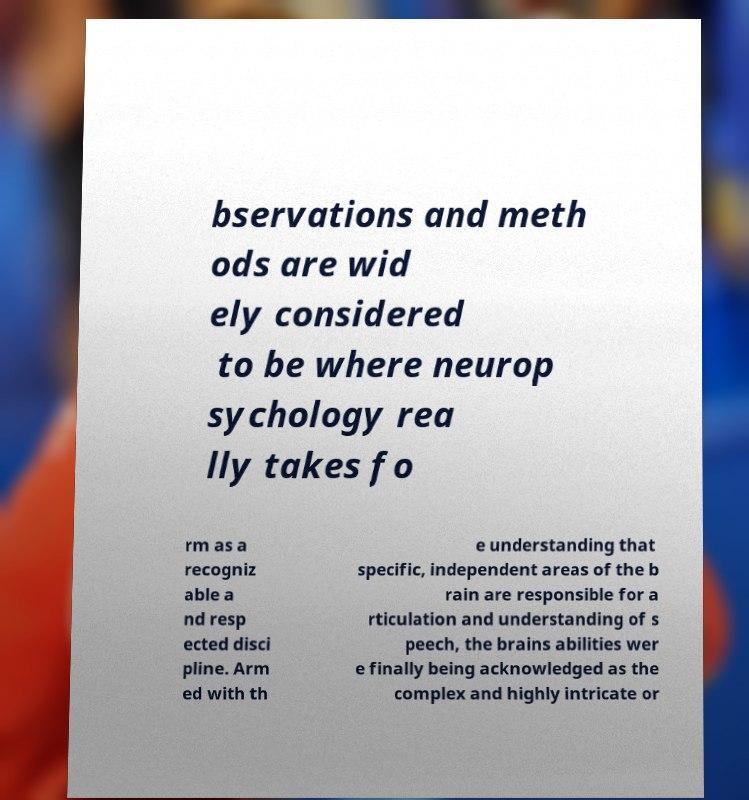Please identify and transcribe the text found in this image. bservations and meth ods are wid ely considered to be where neurop sychology rea lly takes fo rm as a recogniz able a nd resp ected disci pline. Arm ed with th e understanding that specific, independent areas of the b rain are responsible for a rticulation and understanding of s peech, the brains abilities wer e finally being acknowledged as the complex and highly intricate or 